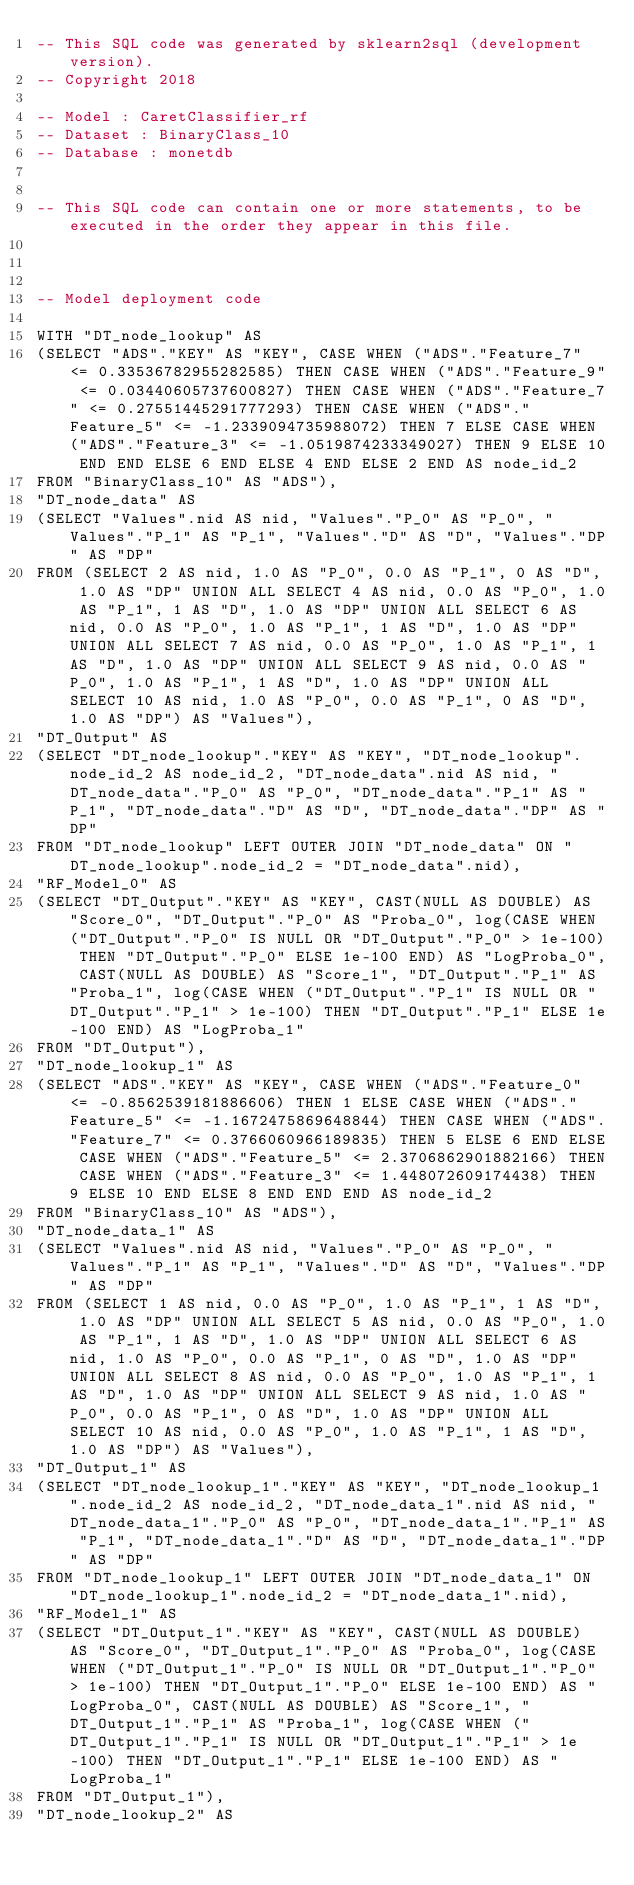<code> <loc_0><loc_0><loc_500><loc_500><_SQL_>-- This SQL code was generated by sklearn2sql (development version).
-- Copyright 2018

-- Model : CaretClassifier_rf
-- Dataset : BinaryClass_10
-- Database : monetdb


-- This SQL code can contain one or more statements, to be executed in the order they appear in this file.



-- Model deployment code

WITH "DT_node_lookup" AS 
(SELECT "ADS"."KEY" AS "KEY", CASE WHEN ("ADS"."Feature_7" <= 0.33536782955282585) THEN CASE WHEN ("ADS"."Feature_9" <= 0.03440605737600827) THEN CASE WHEN ("ADS"."Feature_7" <= 0.27551445291777293) THEN CASE WHEN ("ADS"."Feature_5" <= -1.2339094735988072) THEN 7 ELSE CASE WHEN ("ADS"."Feature_3" <= -1.0519874233349027) THEN 9 ELSE 10 END END ELSE 6 END ELSE 4 END ELSE 2 END AS node_id_2 
FROM "BinaryClass_10" AS "ADS"), 
"DT_node_data" AS 
(SELECT "Values".nid AS nid, "Values"."P_0" AS "P_0", "Values"."P_1" AS "P_1", "Values"."D" AS "D", "Values"."DP" AS "DP" 
FROM (SELECT 2 AS nid, 1.0 AS "P_0", 0.0 AS "P_1", 0 AS "D", 1.0 AS "DP" UNION ALL SELECT 4 AS nid, 0.0 AS "P_0", 1.0 AS "P_1", 1 AS "D", 1.0 AS "DP" UNION ALL SELECT 6 AS nid, 0.0 AS "P_0", 1.0 AS "P_1", 1 AS "D", 1.0 AS "DP" UNION ALL SELECT 7 AS nid, 0.0 AS "P_0", 1.0 AS "P_1", 1 AS "D", 1.0 AS "DP" UNION ALL SELECT 9 AS nid, 0.0 AS "P_0", 1.0 AS "P_1", 1 AS "D", 1.0 AS "DP" UNION ALL SELECT 10 AS nid, 1.0 AS "P_0", 0.0 AS "P_1", 0 AS "D", 1.0 AS "DP") AS "Values"), 
"DT_Output" AS 
(SELECT "DT_node_lookup"."KEY" AS "KEY", "DT_node_lookup".node_id_2 AS node_id_2, "DT_node_data".nid AS nid, "DT_node_data"."P_0" AS "P_0", "DT_node_data"."P_1" AS "P_1", "DT_node_data"."D" AS "D", "DT_node_data"."DP" AS "DP" 
FROM "DT_node_lookup" LEFT OUTER JOIN "DT_node_data" ON "DT_node_lookup".node_id_2 = "DT_node_data".nid), 
"RF_Model_0" AS 
(SELECT "DT_Output"."KEY" AS "KEY", CAST(NULL AS DOUBLE) AS "Score_0", "DT_Output"."P_0" AS "Proba_0", log(CASE WHEN ("DT_Output"."P_0" IS NULL OR "DT_Output"."P_0" > 1e-100) THEN "DT_Output"."P_0" ELSE 1e-100 END) AS "LogProba_0", CAST(NULL AS DOUBLE) AS "Score_1", "DT_Output"."P_1" AS "Proba_1", log(CASE WHEN ("DT_Output"."P_1" IS NULL OR "DT_Output"."P_1" > 1e-100) THEN "DT_Output"."P_1" ELSE 1e-100 END) AS "LogProba_1" 
FROM "DT_Output"), 
"DT_node_lookup_1" AS 
(SELECT "ADS"."KEY" AS "KEY", CASE WHEN ("ADS"."Feature_0" <= -0.8562539181886606) THEN 1 ELSE CASE WHEN ("ADS"."Feature_5" <= -1.1672475869648844) THEN CASE WHEN ("ADS"."Feature_7" <= 0.3766060966189835) THEN 5 ELSE 6 END ELSE CASE WHEN ("ADS"."Feature_5" <= 2.3706862901882166) THEN CASE WHEN ("ADS"."Feature_3" <= 1.448072609174438) THEN 9 ELSE 10 END ELSE 8 END END END AS node_id_2 
FROM "BinaryClass_10" AS "ADS"), 
"DT_node_data_1" AS 
(SELECT "Values".nid AS nid, "Values"."P_0" AS "P_0", "Values"."P_1" AS "P_1", "Values"."D" AS "D", "Values"."DP" AS "DP" 
FROM (SELECT 1 AS nid, 0.0 AS "P_0", 1.0 AS "P_1", 1 AS "D", 1.0 AS "DP" UNION ALL SELECT 5 AS nid, 0.0 AS "P_0", 1.0 AS "P_1", 1 AS "D", 1.0 AS "DP" UNION ALL SELECT 6 AS nid, 1.0 AS "P_0", 0.0 AS "P_1", 0 AS "D", 1.0 AS "DP" UNION ALL SELECT 8 AS nid, 0.0 AS "P_0", 1.0 AS "P_1", 1 AS "D", 1.0 AS "DP" UNION ALL SELECT 9 AS nid, 1.0 AS "P_0", 0.0 AS "P_1", 0 AS "D", 1.0 AS "DP" UNION ALL SELECT 10 AS nid, 0.0 AS "P_0", 1.0 AS "P_1", 1 AS "D", 1.0 AS "DP") AS "Values"), 
"DT_Output_1" AS 
(SELECT "DT_node_lookup_1"."KEY" AS "KEY", "DT_node_lookup_1".node_id_2 AS node_id_2, "DT_node_data_1".nid AS nid, "DT_node_data_1"."P_0" AS "P_0", "DT_node_data_1"."P_1" AS "P_1", "DT_node_data_1"."D" AS "D", "DT_node_data_1"."DP" AS "DP" 
FROM "DT_node_lookup_1" LEFT OUTER JOIN "DT_node_data_1" ON "DT_node_lookup_1".node_id_2 = "DT_node_data_1".nid), 
"RF_Model_1" AS 
(SELECT "DT_Output_1"."KEY" AS "KEY", CAST(NULL AS DOUBLE) AS "Score_0", "DT_Output_1"."P_0" AS "Proba_0", log(CASE WHEN ("DT_Output_1"."P_0" IS NULL OR "DT_Output_1"."P_0" > 1e-100) THEN "DT_Output_1"."P_0" ELSE 1e-100 END) AS "LogProba_0", CAST(NULL AS DOUBLE) AS "Score_1", "DT_Output_1"."P_1" AS "Proba_1", log(CASE WHEN ("DT_Output_1"."P_1" IS NULL OR "DT_Output_1"."P_1" > 1e-100) THEN "DT_Output_1"."P_1" ELSE 1e-100 END) AS "LogProba_1" 
FROM "DT_Output_1"), 
"DT_node_lookup_2" AS </code> 